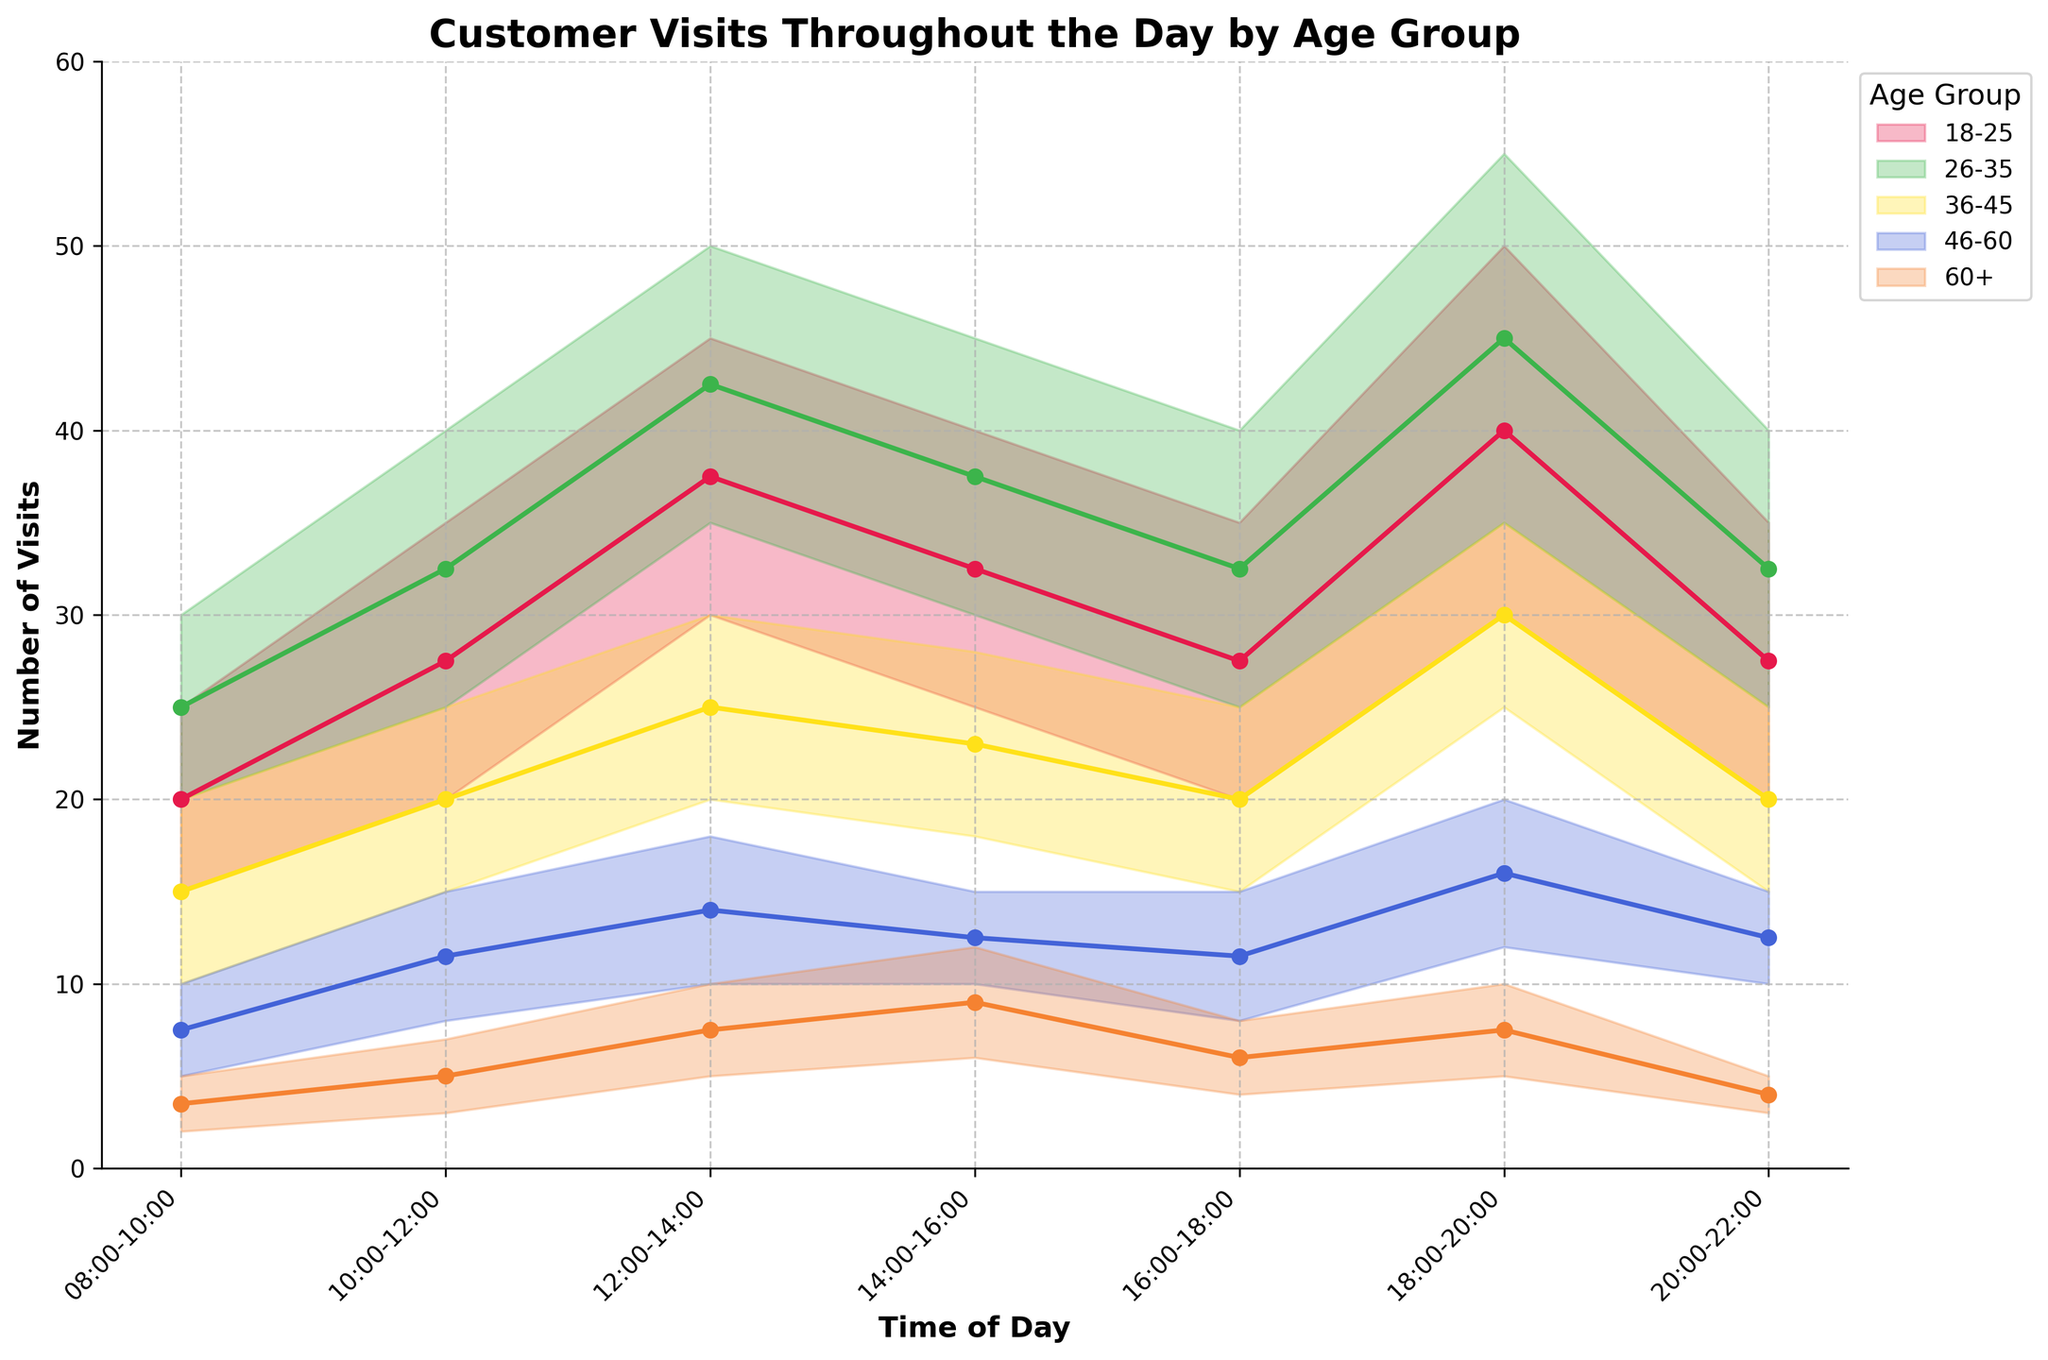What's the overall trend of customer visits throughout the day for the 18-25 age group? To determine the overall trend, look at the filled area and line for the 18-25 age group (represented in a specific color). The highest visits occur between 12:00-14:00 and 18:00-20:00, averaging around 45 and 50 visits, respectively. The number of visits generally peaks during meal times and decreases between those periods.
Answer: Peaks during 12:00-14:00 and 18:00-20:00 During which time period do people aged 46-60 have the least number of visits? Check the plotted range for the 46-60 age group across different time periods. The smallest lower bound is seen from 08:00-10:00.
Answer: 08:00-10:00 Which age group has the highest number of visits during 10:00-12:00? Compare the upper bounds of all age groups during 10:00-12:00. The highest peak is seen in the 26-35 age group at 40 visits.
Answer: 26-35 age group How does the number of visits for people aged 60+ change from 12:00-14:00 to 14:00-16:00? Look at the min and max values for the 60+ age group from 12:00-14:00 (5 to 10) and 14:00-16:00 (6 to 12). The range slightly increases during 14:00-16:00.
Answer: Slight increase Which time period shows the least variation in visit numbers for the 36-45 age group? Compare the range (difference between max and min) for each time period. The smallest range for the 36-45 age group is from 14:00-16:00 with a min of 18 and max of 28, giving a range of 10.
Answer: 14:00-16:00 What is the average number of visits for the 26-35 age group during 18:00-20:00? The min and max values are 35 and 55, respectively. The average is calculated as (35 + 55) / 2.
Answer: 45 During which time period do we see the most significant drop in visits for the 18-25 age group? Compare the average values between consecutive time periods. The most significant drop occurs from 18:00-20:00 average of 40 (20:00-22:00 average: 27.5). The change is 50 to 27.5.
Answer: 20:00-22:00 Which two age groups have the closest range during 16:00-18:00? Calculate the range (max - min) for each age group during 16:00-18:00. The 18-25 and 36-45 age groups both have ranges of 15 and 10, respectively.
Answer: 46-60 and 60+ How do the visit patterns of the 18-25 and 26-35 age groups compare throughout the day? Compare the trends across all times: The 26-35 group consistently sees higher peaks and troughs compared to the 18-25 group, maintaining a higher number of visits overall.
Answer: 26-35 consistently higher 